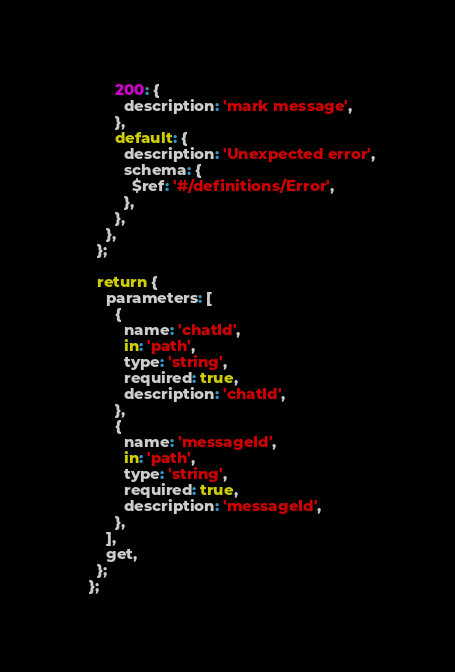Convert code to text. <code><loc_0><loc_0><loc_500><loc_500><_JavaScript_>        200: {
          description: 'mark message',
        },
        default: {
          description: 'Unexpected error',
          schema: {
            $ref: '#/definitions/Error',
          },
        },
      },
    };
  
    return {
      parameters: [
        {
          name: 'chatId',
          in: 'path',
          type: 'string',
          required: true,
          description: 'chatId',
        },
        {
          name: 'messageId',
          in: 'path',
          type: 'string',
          required: true,
          description: 'messageId',
        },
      ],
      get,
    };
  };</code> 